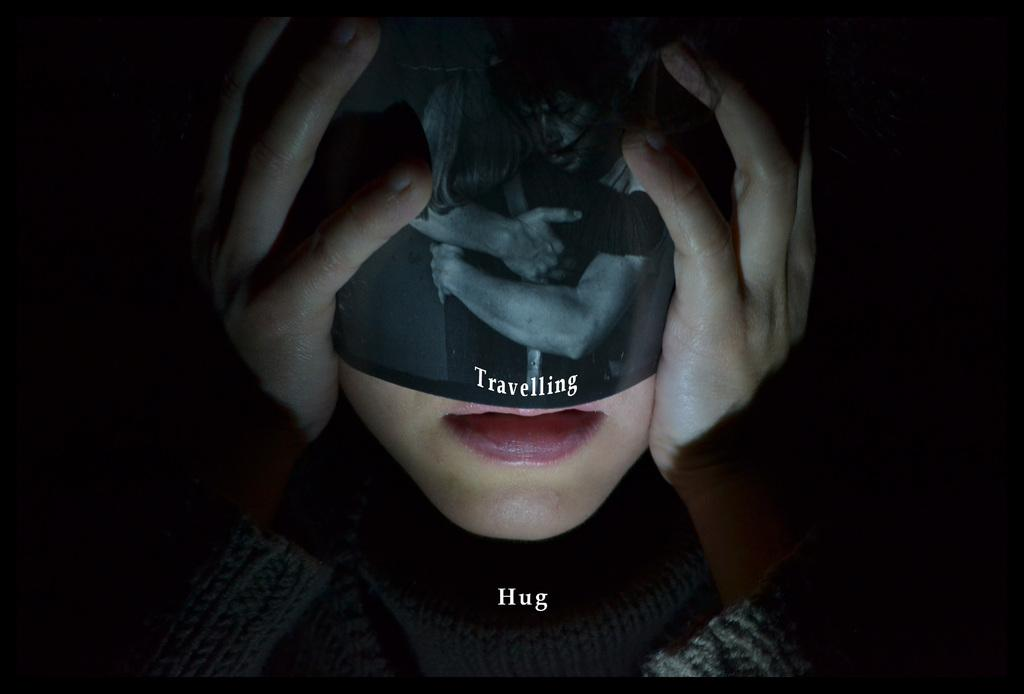Who is present in the image? There is a woman in the image. What is the woman wearing? The woman is wearing an object with text on it. Can you describe the text on the object? Unfortunately, the text on the object cannot be read from the image. What is visible towards the bottom of the image? There is text towards the bottom of the image. How would you describe the overall appearance of the image? The background of the image is dark. What type of substance is being drawn with chalk in the image? There is no chalk or drawing present in the image. 